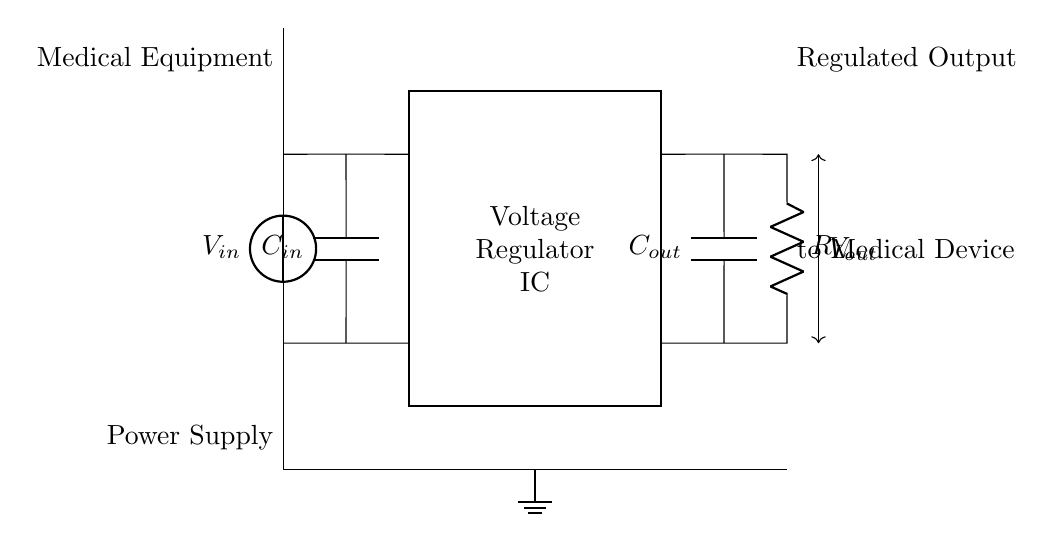What is the input voltage of this circuit? The input voltage, represented as V_in in the circuit, is connected to the voltage source at the left side. This voltage is essential for the operation of the voltage regulator.
Answer: V_in What is the function of the voltage regulator? The voltage regulator is used to maintain a constant output voltage regardless of input voltage variations or load conditions. Its primary purpose is to provide a stable voltage to the medical equipment.
Answer: Stable output voltage How many capacitors are in this circuit? There are two capacitors labeled C_in and C_out. C_in is connected at the input side, and C_out is connected at the output side of the regulator to smooth voltage and filter noise.
Answer: Two capacitors What does R_L represent in this circuit? R_L represents the load resistor connected to the output of the voltage regulator. It indicates the load that the output voltage will power in the medical device.
Answer: Load resistor What is the purpose of C_out in this voltage regulator circuit? C_out is used as an output capacitor that stabilizes the output voltage and filters any high-frequency noise, ensuring a clean voltage supply to the medical device.
Answer: Stabilization and filtering What can be inferred about the connection from V_out to the medical device? The connection from V_out to the medical device indicates that the regulated output voltage is intended to provide power directly to the device, ensuring its proper operation.
Answer: Direct power supply What type of circuit is this? This circuit is a voltage regulator circuit specifically designed for medical equipment power supplies. It ensures that the medical devices receive a consistent and reliable voltage.
Answer: Voltage regulator circuit 